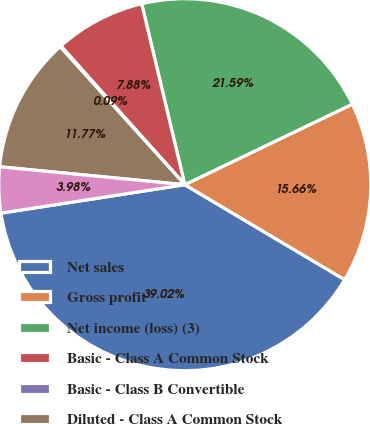Convert chart to OTSL. <chart><loc_0><loc_0><loc_500><loc_500><pie_chart><fcel>Net sales<fcel>Gross profit<fcel>Net income (loss) (3)<fcel>Basic - Class A Common Stock<fcel>Basic - Class B Convertible<fcel>Diluted - Class A Common Stock<fcel>Diluted - Class B Convertible<nl><fcel>39.02%<fcel>15.66%<fcel>21.59%<fcel>7.88%<fcel>0.09%<fcel>11.77%<fcel>3.98%<nl></chart> 